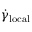<formula> <loc_0><loc_0><loc_500><loc_500>\dot { \gamma } _ { l o c a l }</formula> 